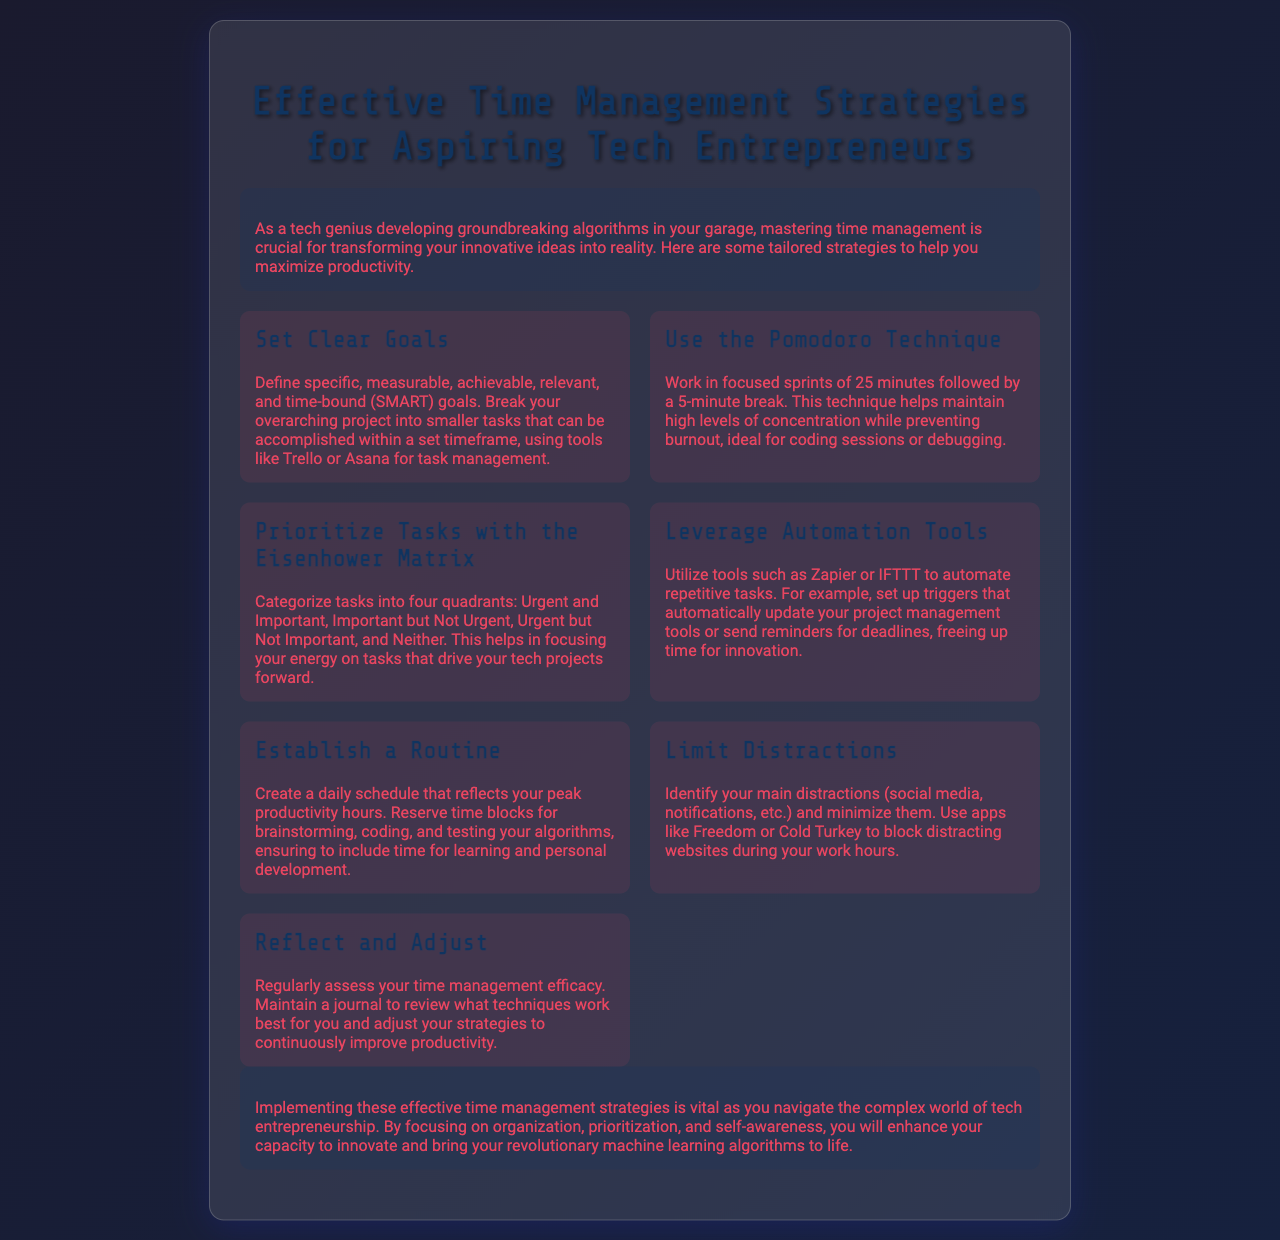What is the title of the brochure? The title is prominently displayed at the top of the document.
Answer: Effective Time Management Strategies for Aspiring Tech Entrepreneurs What technique involves working in focused sprints of 25 minutes? This technique is specifically mentioned in the strategies section of the document.
Answer: Pomodoro Technique How many quadrants are in the Eisenhower Matrix? The document describes the matrix categorizing tasks into four quadrants.
Answer: Four What do you need to create according to the Establish a Routine strategy? The document suggests creating something that reflects productivity.
Answer: Daily schedule Which tools are recommended for automating repetitive tasks? The document names specific tools for automation in the relevant strategy section.
Answer: Zapier or IFTTT What should you maintain to assess time management efficacy? The document mentions this method for regular assessment.
Answer: Journal What color is used for the text in the brochure? This detail relates to the visual aspects of the document.
Answer: Pink 